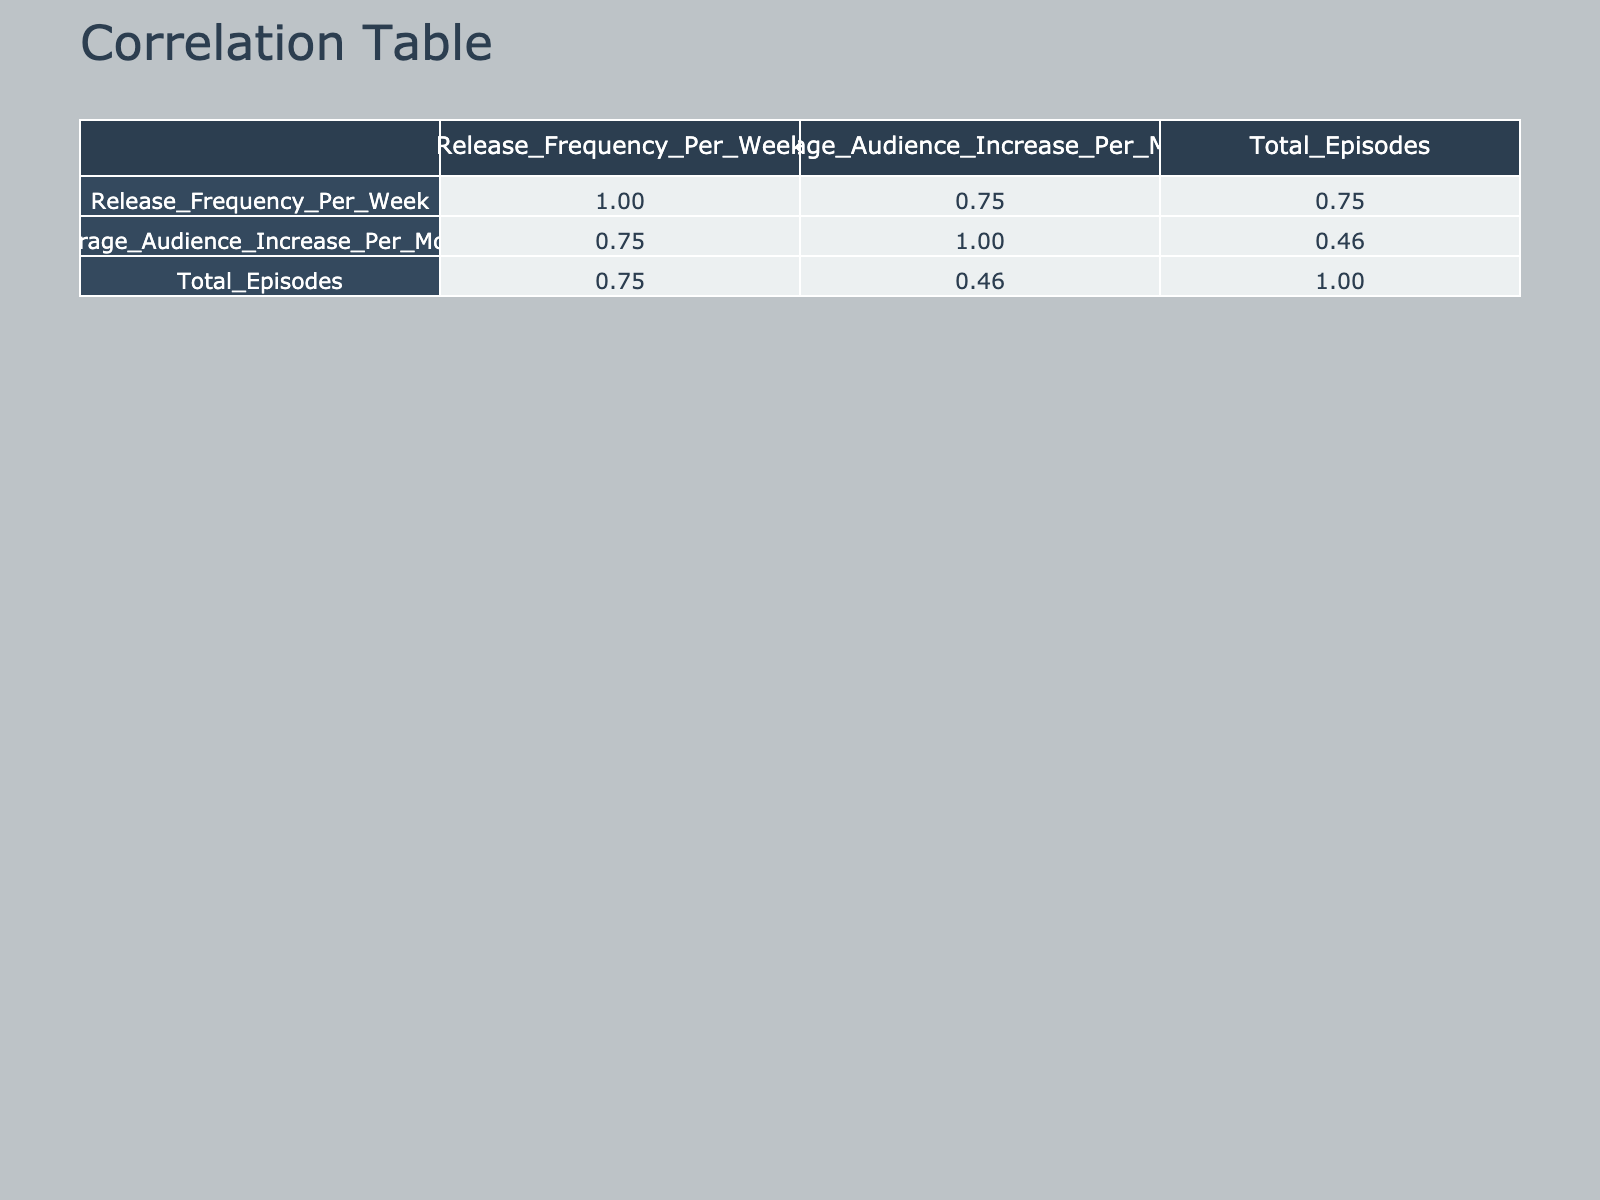What is the release frequency of TravelTales? From the table, we can locate TravelTales, which is in the row corresponding to that podcast. The column for Release Frequency Per Week shows the value of 4.
Answer: 4 What is the average audience increase per month for podcasts with a release frequency of 2? We look at the two podcasts with a release frequency of 2: CuriosityChamber and MindfulMoments. Their audience increases are 100 and 120, respectively. The average is calculated as (100 + 120) / 2 = 110.
Answer: 110 Does TechTalkToday have a higher average audience increase per month than HiddenGemsPod? The table shows TechTalkToday has a value of 250 for average audience increase while HiddenGemsPod has 150. Since 250 is greater than 150, TechTalkToday has a higher increase.
Answer: Yes Which podcast has the highest average audience increase per month? By scanning through the average audience increase column, we find that TravelTales has the highest value at 300.
Answer: TravelTales What is the total number of episodes for podcasts with a release frequency of 1? The podcasts with a release frequency of 1 are TrueCrimeCaught and HistoryUnplugged, which have 45 and 50 episodes respectively. Thus, the total is 45 + 50 = 95.
Answer: 95 Is the average audience increase per month for podcasts in the Arts genre higher than that in the Food genre? HiddenGemsPod, the only Arts genre podcast, has an audience increase of 150, and CulinaryChronicles from the Food genre has 95. Since 150 is greater than 95, the statement is true.
Answer: Yes What is the difference between the average audience increase of the podcast with the highest release frequency (TechTalkToday) and the podcast with the lowest (TrueCrimeCaught)? TechTalkToday has an audience increase of 250 and TrueCrimeCaught has 200. The difference is 250 - 200 = 50.
Answer: 50 Which genre has the lowest average audience increase per month, and what is that value? To find this, I compute the average audience increases for each genre: Arts (150), Science (100), True Crime (200), Technology (250), History (80), Self-Help (120), Entertainment (90), Business (175), and Food (95). The lowest is in the History genre with an average increase of 80.
Answer: History, 80 Is there a podcast with a release frequency of 3 that has more than 170 average audience increase per month? The rows for BusinessBreakdown show a release frequency of 3 and an audience increase of 175, which is indeed more than 170. Therefore, the answer is yes.
Answer: Yes 